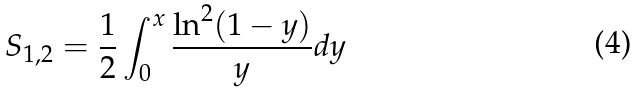<formula> <loc_0><loc_0><loc_500><loc_500>S _ { 1 , 2 } = \frac { 1 } { 2 } \int ^ { x } _ { 0 } \frac { \ln ^ { 2 } ( 1 - y ) } { y } d y</formula> 